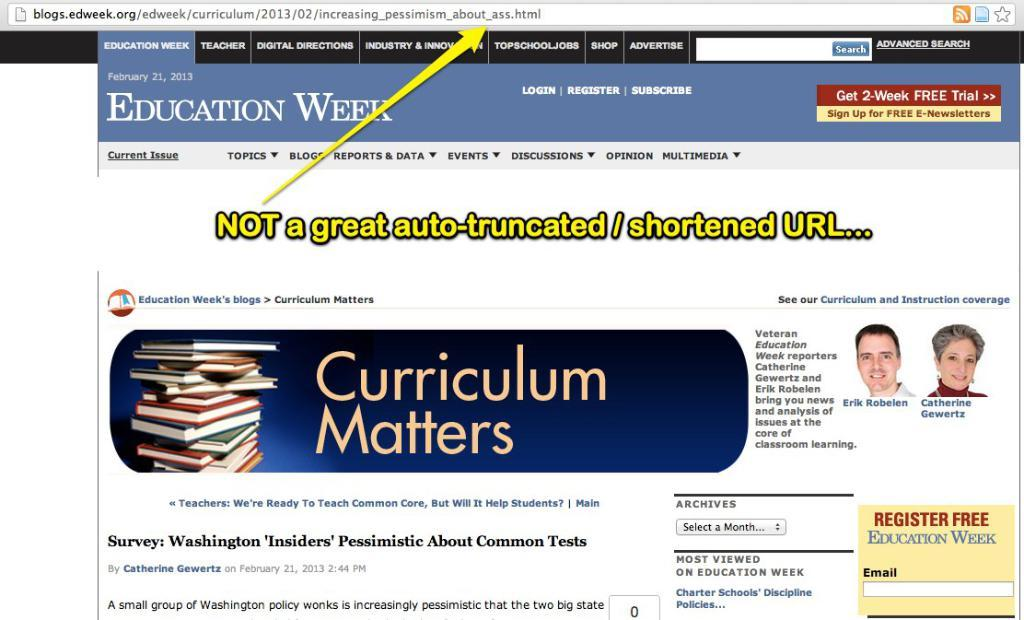<image>
Provide a brief description of the given image. A website for Education Week displays a banner for Curriculum Matters 